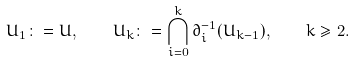Convert formula to latex. <formula><loc_0><loc_0><loc_500><loc_500>U _ { 1 } \colon = U , \quad U _ { k } \colon = \bigcap _ { i = 0 } ^ { k } \partial _ { i } ^ { - 1 } ( U _ { k - 1 } ) , \quad k \geq 2 .</formula> 